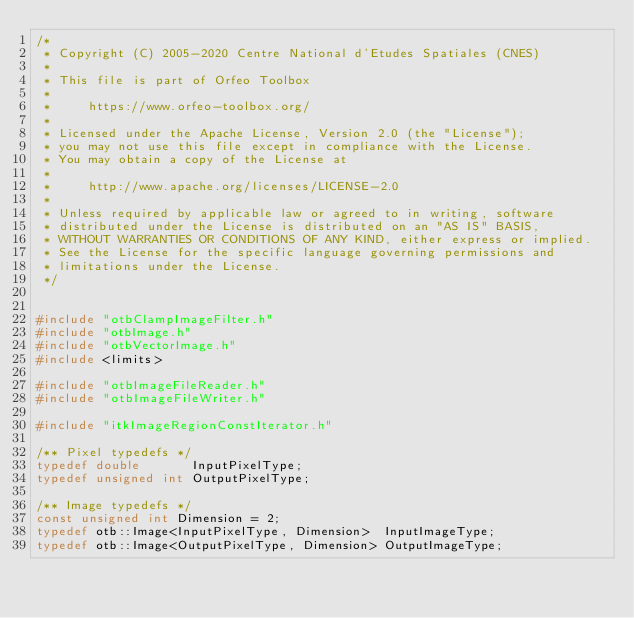<code> <loc_0><loc_0><loc_500><loc_500><_C++_>/*
 * Copyright (C) 2005-2020 Centre National d'Etudes Spatiales (CNES)
 *
 * This file is part of Orfeo Toolbox
 *
 *     https://www.orfeo-toolbox.org/
 *
 * Licensed under the Apache License, Version 2.0 (the "License");
 * you may not use this file except in compliance with the License.
 * You may obtain a copy of the License at
 *
 *     http://www.apache.org/licenses/LICENSE-2.0
 *
 * Unless required by applicable law or agreed to in writing, software
 * distributed under the License is distributed on an "AS IS" BASIS,
 * WITHOUT WARRANTIES OR CONDITIONS OF ANY KIND, either express or implied.
 * See the License for the specific language governing permissions and
 * limitations under the License.
 */


#include "otbClampImageFilter.h"
#include "otbImage.h"
#include "otbVectorImage.h"
#include <limits>

#include "otbImageFileReader.h"
#include "otbImageFileWriter.h"

#include "itkImageRegionConstIterator.h"

/** Pixel typedefs */
typedef double       InputPixelType;
typedef unsigned int OutputPixelType;

/** Image typedefs */
const unsigned int Dimension = 2;
typedef otb::Image<InputPixelType, Dimension>  InputImageType;
typedef otb::Image<OutputPixelType, Dimension> OutputImageType;
</code> 